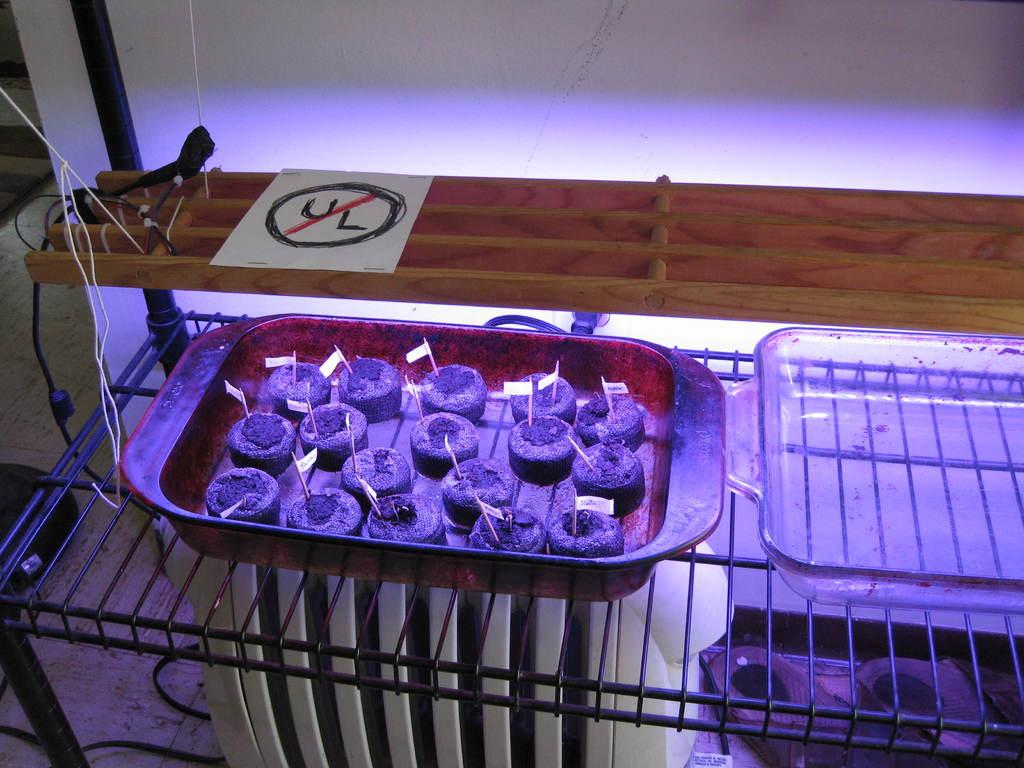<image>
Provide a brief description of the given image. A page with the letters UL with a red line through them is visible to the top left. 